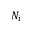<formula> <loc_0><loc_0><loc_500><loc_500>N _ { i }</formula> 